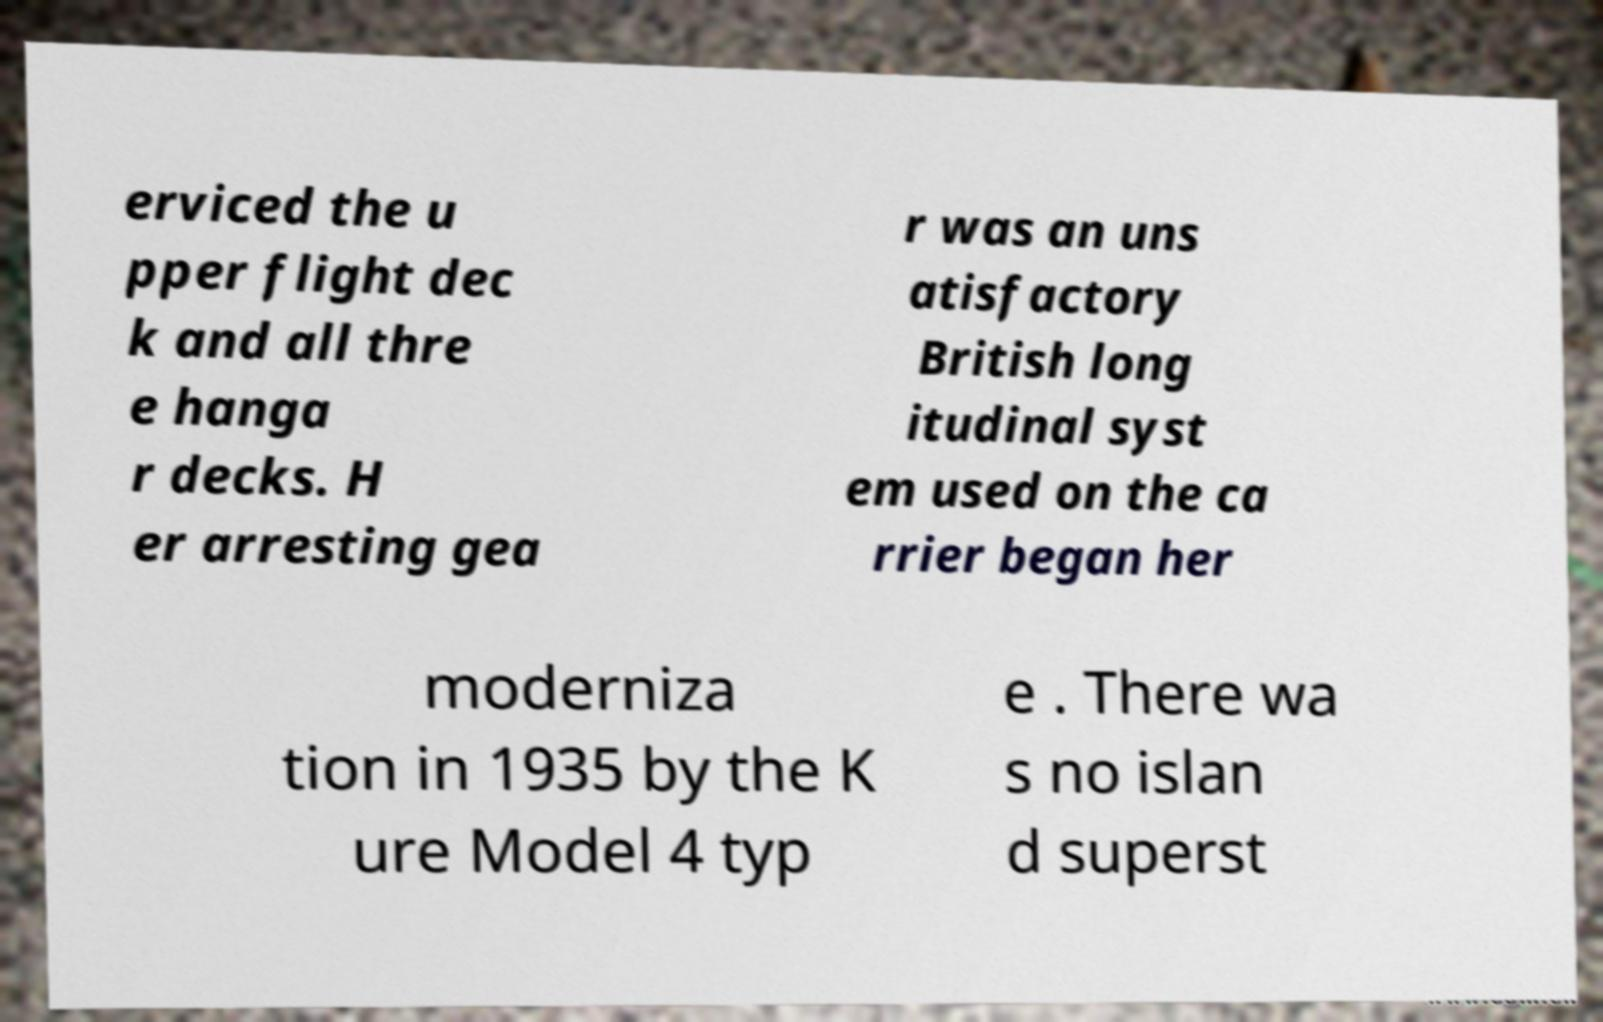I need the written content from this picture converted into text. Can you do that? erviced the u pper flight dec k and all thre e hanga r decks. H er arresting gea r was an uns atisfactory British long itudinal syst em used on the ca rrier began her moderniza tion in 1935 by the K ure Model 4 typ e . There wa s no islan d superst 